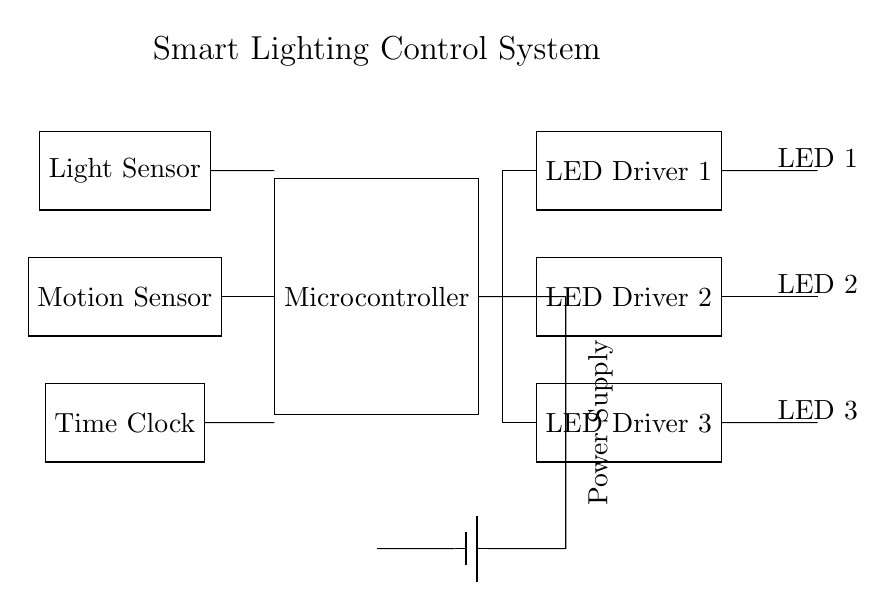What are the main components of the circuit? The circuit consists of a microcontroller, light sensor, motion sensor, time clock, power supply, LED drivers, and LEDs.
Answer: microcontroller, light sensor, motion sensor, time clock, power supply, LED drivers, LEDs How many LED drivers are present in the circuit? There are three LED drivers included in the diagram as indicated by the labeled components.
Answer: 3 Which component detects ambient light? The component responsible for detecting ambient light in the circuit is labeled as "Light Sensor".
Answer: Light Sensor What is the function of the microcontroller in this circuit? The microcontroller processes inputs from the light sensor, motion sensor, and time clock to control the LED drivers accordingly.
Answer: control How do the sensors interact with the microcontroller? The light sensor, motion sensor, and time clock are all connected to the microcontroller, which means they provide input data for the microcontroller’s processing and decision-making.
Answer: input data If no motion is detected, which sensor controls the LEDs? In the absence of motion detection, the light sensor would primarily influence the LED state by measuring ambient light levels.
Answer: Light Sensor What powers the entire circuit? The circuit is powered by a battery, as indicated by the labeled "Power Supply" component.
Answer: Battery 